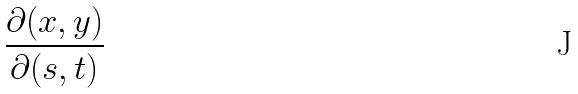<formula> <loc_0><loc_0><loc_500><loc_500>\frac { \partial ( x , y ) } { \partial ( s , t ) }</formula> 